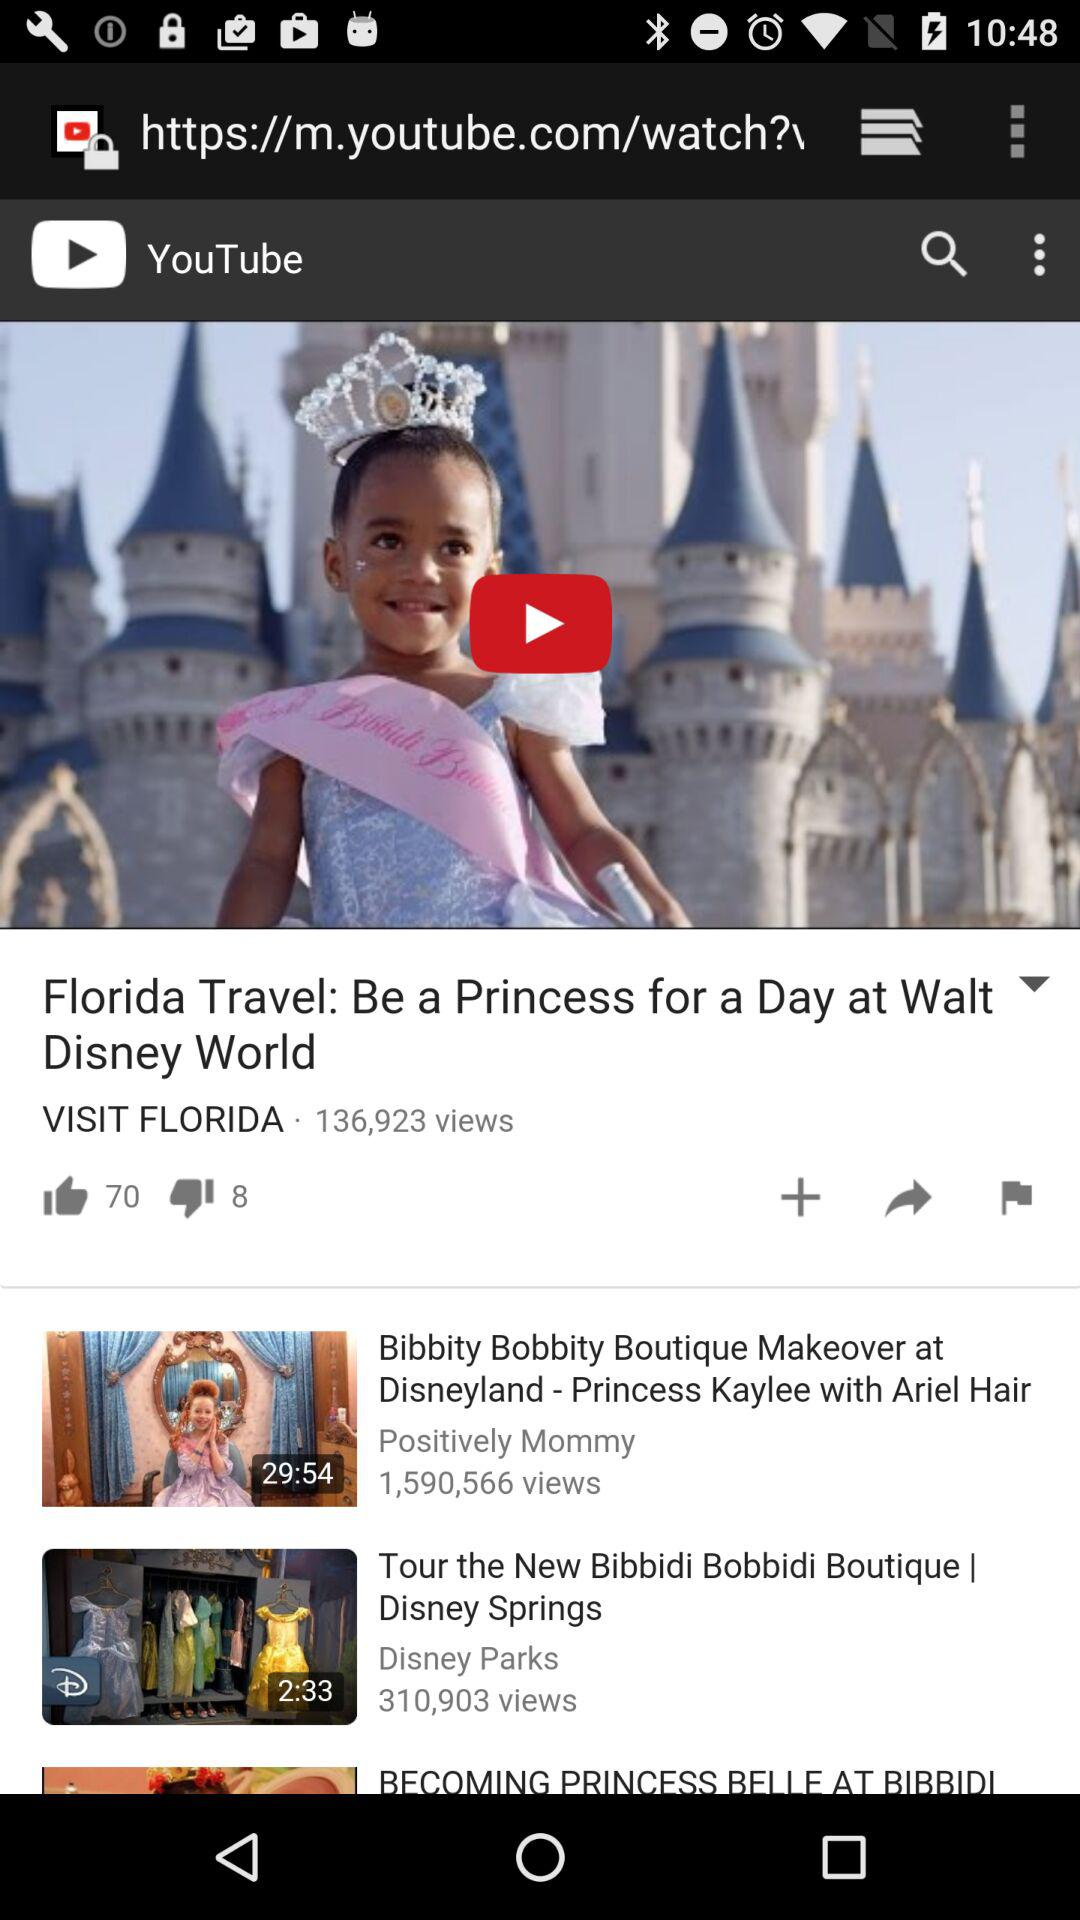What is the duration of the "Bibbity Bobbity Boutique Makeover at Disneyland - Princess Kaylee with Ariel Hair" video? The duration of the video is 29:54. 